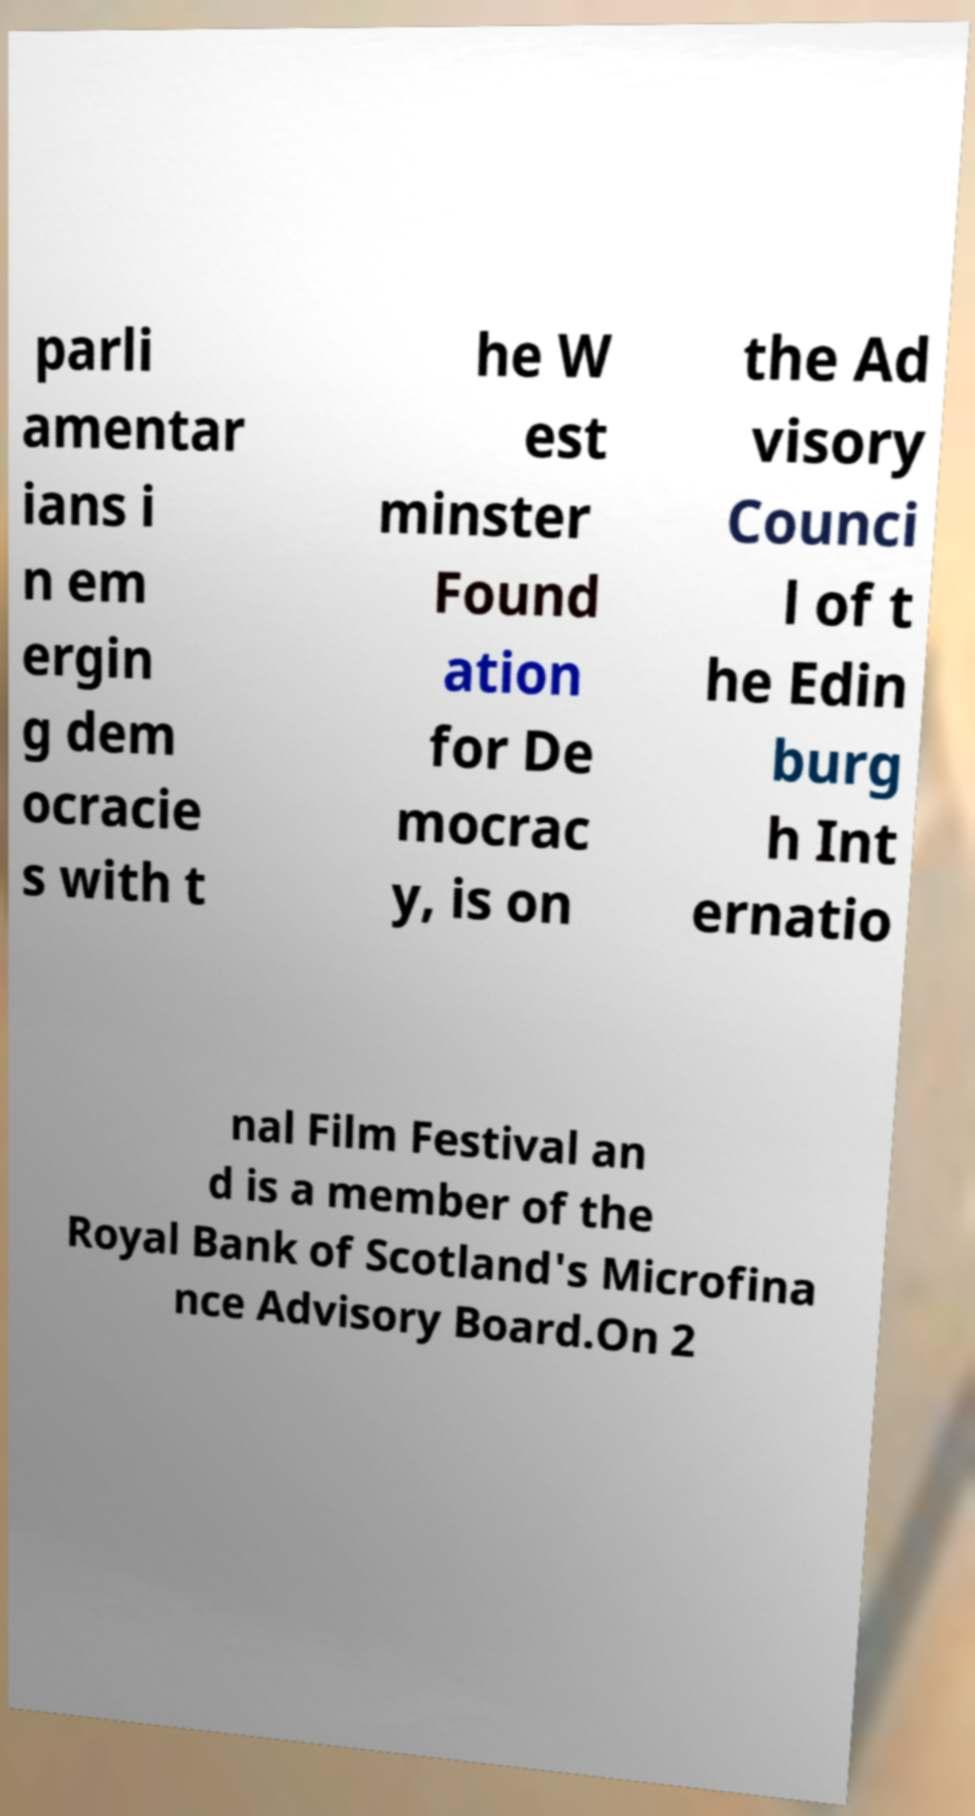Please identify and transcribe the text found in this image. parli amentar ians i n em ergin g dem ocracie s with t he W est minster Found ation for De mocrac y, is on the Ad visory Counci l of t he Edin burg h Int ernatio nal Film Festival an d is a member of the Royal Bank of Scotland's Microfina nce Advisory Board.On 2 